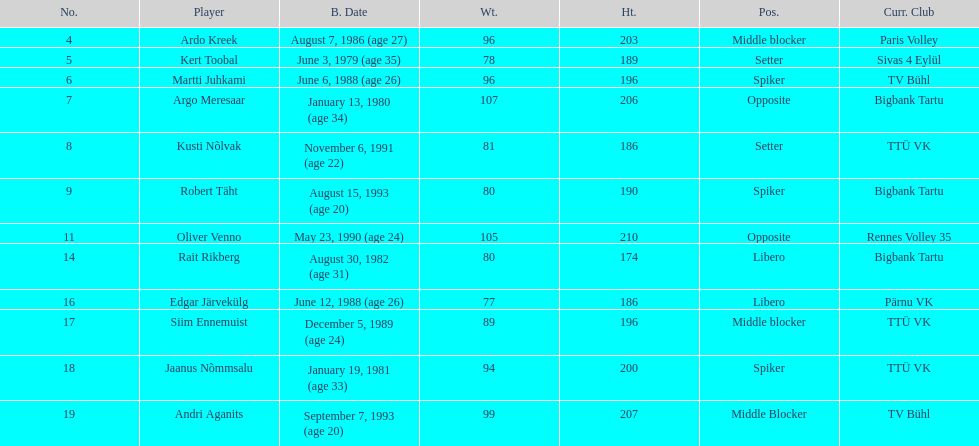Which players played the same position as ardo kreek? Siim Ennemuist, Andri Aganits. 